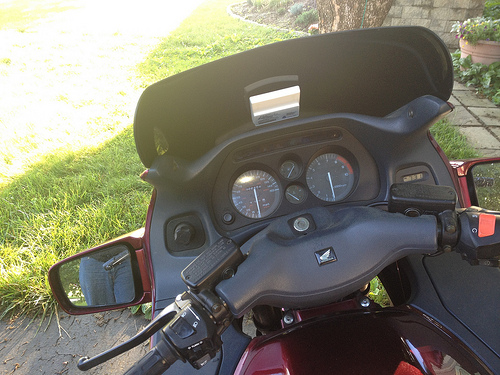<image>
Is there a man in front of the motocycle? No. The man is not in front of the motocycle. The spatial positioning shows a different relationship between these objects. Where is the motorcycle in relation to the tree? Is it to the left of the tree? No. The motorcycle is not to the left of the tree. From this viewpoint, they have a different horizontal relationship. 